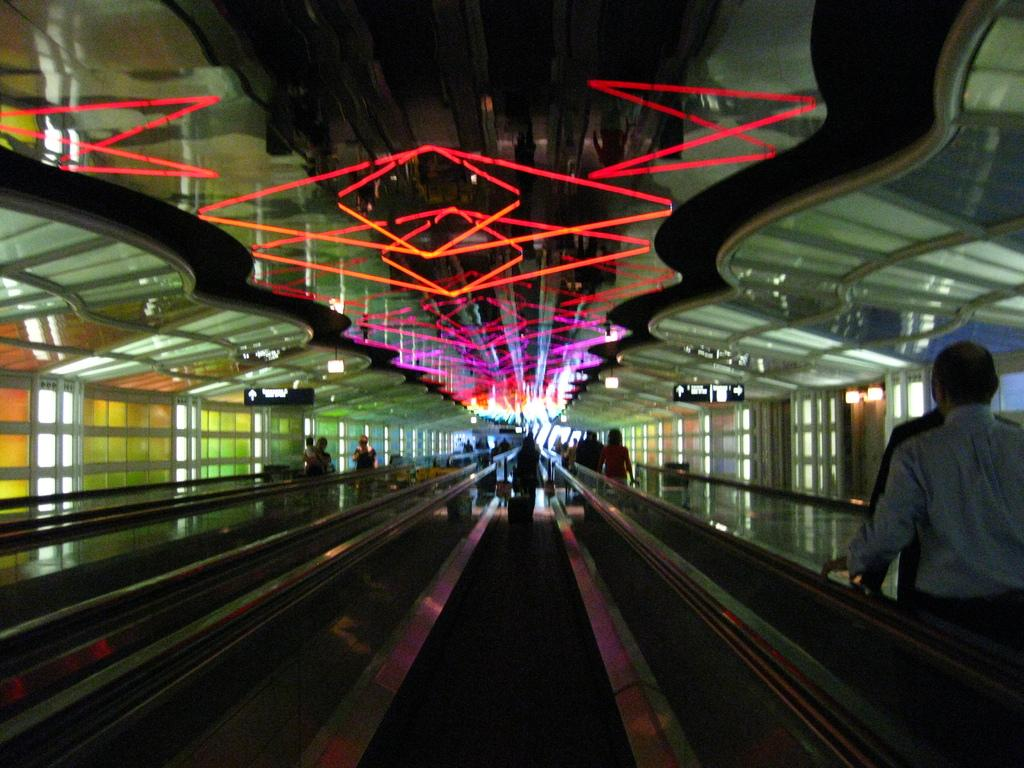What type of transportation equipment is present in the image? There are escalators in the image. Can you describe the people in the image? There are people in the image. What can be seen on the roof in the image? There are light arrangements on the roof in the image. What type of windows are present in the image? There are glass windows in the image. What type of brass instrument is being played by the worm in the image? There is no brass instrument or worm present in the image. 